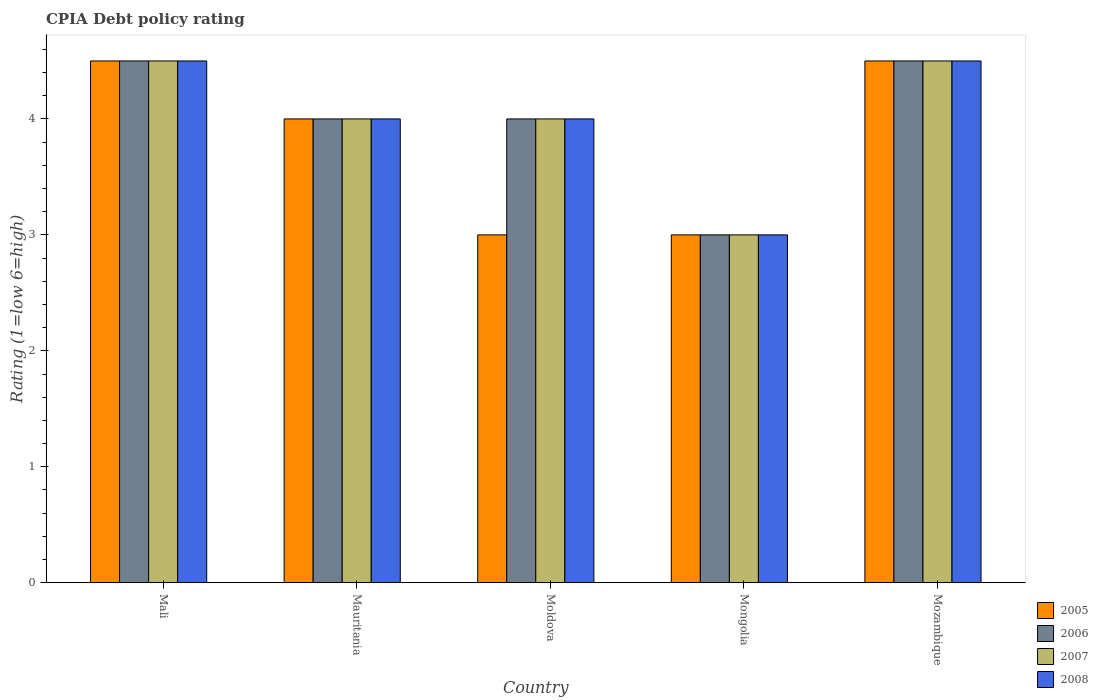How many different coloured bars are there?
Give a very brief answer. 4. How many groups of bars are there?
Provide a succinct answer. 5. Are the number of bars on each tick of the X-axis equal?
Offer a terse response. Yes. How many bars are there on the 3rd tick from the right?
Give a very brief answer. 4. What is the label of the 1st group of bars from the left?
Provide a succinct answer. Mali. In how many cases, is the number of bars for a given country not equal to the number of legend labels?
Keep it short and to the point. 0. In which country was the CPIA rating in 2008 maximum?
Your answer should be compact. Mali. In which country was the CPIA rating in 2005 minimum?
Provide a succinct answer. Moldova. What is the total CPIA rating in 2005 in the graph?
Provide a short and direct response. 19. What is the difference between the CPIA rating in 2008 in Moldova and that in Mozambique?
Your answer should be compact. -0.5. What is the difference between the CPIA rating in 2007 in Moldova and the CPIA rating in 2006 in Mongolia?
Offer a terse response. 1. What is the average CPIA rating in 2005 per country?
Your answer should be very brief. 3.8. What is the difference between the CPIA rating of/in 2008 and CPIA rating of/in 2006 in Moldova?
Keep it short and to the point. 0. In how many countries, is the CPIA rating in 2008 greater than 2.8?
Offer a very short reply. 5. What is the ratio of the CPIA rating in 2005 in Mauritania to that in Mongolia?
Make the answer very short. 1.33. Is the CPIA rating in 2006 in Mali less than that in Moldova?
Offer a very short reply. No. What is the difference between the highest and the second highest CPIA rating in 2007?
Offer a very short reply. 0.5. What is the difference between the highest and the lowest CPIA rating in 2005?
Keep it short and to the point. 1.5. What does the 3rd bar from the left in Mongolia represents?
Give a very brief answer. 2007. Is it the case that in every country, the sum of the CPIA rating in 2005 and CPIA rating in 2008 is greater than the CPIA rating in 2007?
Your answer should be compact. Yes. Are the values on the major ticks of Y-axis written in scientific E-notation?
Make the answer very short. No. Does the graph contain any zero values?
Your response must be concise. No. How many legend labels are there?
Offer a terse response. 4. How are the legend labels stacked?
Ensure brevity in your answer.  Vertical. What is the title of the graph?
Offer a very short reply. CPIA Debt policy rating. What is the label or title of the X-axis?
Give a very brief answer. Country. What is the label or title of the Y-axis?
Keep it short and to the point. Rating (1=low 6=high). What is the Rating (1=low 6=high) of 2008 in Mali?
Provide a succinct answer. 4.5. What is the Rating (1=low 6=high) in 2005 in Mauritania?
Offer a very short reply. 4. What is the Rating (1=low 6=high) in 2006 in Mauritania?
Keep it short and to the point. 4. What is the Rating (1=low 6=high) in 2005 in Moldova?
Give a very brief answer. 3. What is the Rating (1=low 6=high) in 2006 in Moldova?
Offer a very short reply. 4. What is the Rating (1=low 6=high) in 2007 in Moldova?
Give a very brief answer. 4. What is the Rating (1=low 6=high) of 2008 in Mongolia?
Keep it short and to the point. 3. What is the Rating (1=low 6=high) in 2005 in Mozambique?
Your answer should be compact. 4.5. What is the Rating (1=low 6=high) in 2006 in Mozambique?
Provide a succinct answer. 4.5. What is the Rating (1=low 6=high) of 2008 in Mozambique?
Make the answer very short. 4.5. Across all countries, what is the maximum Rating (1=low 6=high) of 2006?
Your response must be concise. 4.5. Across all countries, what is the maximum Rating (1=low 6=high) of 2007?
Your answer should be compact. 4.5. Across all countries, what is the maximum Rating (1=low 6=high) of 2008?
Make the answer very short. 4.5. Across all countries, what is the minimum Rating (1=low 6=high) of 2005?
Your response must be concise. 3. Across all countries, what is the minimum Rating (1=low 6=high) in 2006?
Your answer should be very brief. 3. Across all countries, what is the minimum Rating (1=low 6=high) of 2007?
Your answer should be compact. 3. Across all countries, what is the minimum Rating (1=low 6=high) in 2008?
Provide a short and direct response. 3. What is the total Rating (1=low 6=high) of 2005 in the graph?
Offer a very short reply. 19. What is the total Rating (1=low 6=high) of 2008 in the graph?
Offer a terse response. 20. What is the difference between the Rating (1=low 6=high) of 2005 in Mali and that in Mauritania?
Offer a terse response. 0.5. What is the difference between the Rating (1=low 6=high) in 2007 in Mali and that in Mauritania?
Make the answer very short. 0.5. What is the difference between the Rating (1=low 6=high) in 2008 in Mali and that in Mauritania?
Make the answer very short. 0.5. What is the difference between the Rating (1=low 6=high) of 2005 in Mali and that in Mongolia?
Keep it short and to the point. 1.5. What is the difference between the Rating (1=low 6=high) in 2007 in Mali and that in Mongolia?
Provide a succinct answer. 1.5. What is the difference between the Rating (1=low 6=high) in 2008 in Mali and that in Mongolia?
Offer a terse response. 1.5. What is the difference between the Rating (1=low 6=high) of 2006 in Mali and that in Mozambique?
Your answer should be compact. 0. What is the difference between the Rating (1=low 6=high) in 2008 in Mali and that in Mozambique?
Offer a very short reply. 0. What is the difference between the Rating (1=low 6=high) in 2006 in Mauritania and that in Moldova?
Offer a terse response. 0. What is the difference between the Rating (1=low 6=high) in 2007 in Mauritania and that in Moldova?
Make the answer very short. 0. What is the difference between the Rating (1=low 6=high) in 2008 in Mauritania and that in Moldova?
Provide a succinct answer. 0. What is the difference between the Rating (1=low 6=high) of 2008 in Mauritania and that in Mongolia?
Your answer should be very brief. 1. What is the difference between the Rating (1=low 6=high) of 2005 in Mauritania and that in Mozambique?
Offer a very short reply. -0.5. What is the difference between the Rating (1=low 6=high) in 2006 in Mauritania and that in Mozambique?
Offer a terse response. -0.5. What is the difference between the Rating (1=low 6=high) in 2007 in Mauritania and that in Mozambique?
Your answer should be very brief. -0.5. What is the difference between the Rating (1=low 6=high) in 2005 in Moldova and that in Mongolia?
Your answer should be very brief. 0. What is the difference between the Rating (1=low 6=high) of 2007 in Moldova and that in Mongolia?
Provide a succinct answer. 1. What is the difference between the Rating (1=low 6=high) in 2008 in Moldova and that in Mongolia?
Provide a succinct answer. 1. What is the difference between the Rating (1=low 6=high) in 2005 in Moldova and that in Mozambique?
Your answer should be very brief. -1.5. What is the difference between the Rating (1=low 6=high) of 2006 in Moldova and that in Mozambique?
Your answer should be compact. -0.5. What is the difference between the Rating (1=low 6=high) of 2007 in Moldova and that in Mozambique?
Provide a succinct answer. -0.5. What is the difference between the Rating (1=low 6=high) in 2008 in Moldova and that in Mozambique?
Ensure brevity in your answer.  -0.5. What is the difference between the Rating (1=low 6=high) in 2006 in Mongolia and that in Mozambique?
Keep it short and to the point. -1.5. What is the difference between the Rating (1=low 6=high) in 2005 in Mali and the Rating (1=low 6=high) in 2006 in Mauritania?
Give a very brief answer. 0.5. What is the difference between the Rating (1=low 6=high) of 2005 in Mali and the Rating (1=low 6=high) of 2008 in Mauritania?
Ensure brevity in your answer.  0.5. What is the difference between the Rating (1=low 6=high) in 2006 in Mali and the Rating (1=low 6=high) in 2007 in Mauritania?
Keep it short and to the point. 0.5. What is the difference between the Rating (1=low 6=high) of 2007 in Mali and the Rating (1=low 6=high) of 2008 in Mauritania?
Provide a succinct answer. 0.5. What is the difference between the Rating (1=low 6=high) in 2006 in Mali and the Rating (1=low 6=high) in 2008 in Moldova?
Provide a short and direct response. 0.5. What is the difference between the Rating (1=low 6=high) of 2005 in Mali and the Rating (1=low 6=high) of 2006 in Mozambique?
Your answer should be compact. 0. What is the difference between the Rating (1=low 6=high) of 2006 in Mali and the Rating (1=low 6=high) of 2008 in Mozambique?
Keep it short and to the point. 0. What is the difference between the Rating (1=low 6=high) in 2005 in Mauritania and the Rating (1=low 6=high) in 2006 in Moldova?
Your answer should be compact. 0. What is the difference between the Rating (1=low 6=high) in 2006 in Mauritania and the Rating (1=low 6=high) in 2008 in Mongolia?
Your response must be concise. 1. What is the difference between the Rating (1=low 6=high) of 2005 in Mauritania and the Rating (1=low 6=high) of 2006 in Mozambique?
Your answer should be very brief. -0.5. What is the difference between the Rating (1=low 6=high) in 2005 in Mauritania and the Rating (1=low 6=high) in 2007 in Mozambique?
Ensure brevity in your answer.  -0.5. What is the difference between the Rating (1=low 6=high) of 2005 in Mauritania and the Rating (1=low 6=high) of 2008 in Mozambique?
Provide a short and direct response. -0.5. What is the difference between the Rating (1=low 6=high) in 2006 in Mauritania and the Rating (1=low 6=high) in 2007 in Mozambique?
Your answer should be very brief. -0.5. What is the difference between the Rating (1=low 6=high) of 2007 in Mauritania and the Rating (1=low 6=high) of 2008 in Mozambique?
Provide a succinct answer. -0.5. What is the difference between the Rating (1=low 6=high) in 2005 in Moldova and the Rating (1=low 6=high) in 2007 in Mongolia?
Ensure brevity in your answer.  0. What is the difference between the Rating (1=low 6=high) of 2005 in Moldova and the Rating (1=low 6=high) of 2008 in Mongolia?
Make the answer very short. 0. What is the difference between the Rating (1=low 6=high) in 2006 in Moldova and the Rating (1=low 6=high) in 2007 in Mongolia?
Your answer should be very brief. 1. What is the difference between the Rating (1=low 6=high) of 2006 in Moldova and the Rating (1=low 6=high) of 2008 in Mongolia?
Offer a very short reply. 1. What is the difference between the Rating (1=low 6=high) of 2007 in Moldova and the Rating (1=low 6=high) of 2008 in Mongolia?
Your answer should be compact. 1. What is the difference between the Rating (1=low 6=high) of 2005 in Moldova and the Rating (1=low 6=high) of 2006 in Mozambique?
Your response must be concise. -1.5. What is the difference between the Rating (1=low 6=high) of 2005 in Moldova and the Rating (1=low 6=high) of 2007 in Mozambique?
Offer a terse response. -1.5. What is the difference between the Rating (1=low 6=high) in 2006 in Moldova and the Rating (1=low 6=high) in 2007 in Mozambique?
Your answer should be compact. -0.5. What is the difference between the Rating (1=low 6=high) of 2007 in Moldova and the Rating (1=low 6=high) of 2008 in Mozambique?
Make the answer very short. -0.5. What is the difference between the Rating (1=low 6=high) of 2005 in Mongolia and the Rating (1=low 6=high) of 2006 in Mozambique?
Your answer should be compact. -1.5. What is the difference between the Rating (1=low 6=high) in 2005 in Mongolia and the Rating (1=low 6=high) in 2008 in Mozambique?
Provide a short and direct response. -1.5. What is the difference between the Rating (1=low 6=high) in 2006 in Mongolia and the Rating (1=low 6=high) in 2008 in Mozambique?
Offer a very short reply. -1.5. What is the difference between the Rating (1=low 6=high) of 2007 in Mongolia and the Rating (1=low 6=high) of 2008 in Mozambique?
Ensure brevity in your answer.  -1.5. What is the average Rating (1=low 6=high) in 2007 per country?
Make the answer very short. 4. What is the difference between the Rating (1=low 6=high) in 2005 and Rating (1=low 6=high) in 2007 in Mali?
Offer a very short reply. 0. What is the difference between the Rating (1=low 6=high) in 2006 and Rating (1=low 6=high) in 2008 in Mali?
Give a very brief answer. 0. What is the difference between the Rating (1=low 6=high) of 2007 and Rating (1=low 6=high) of 2008 in Mali?
Provide a short and direct response. 0. What is the difference between the Rating (1=low 6=high) in 2005 and Rating (1=low 6=high) in 2006 in Mauritania?
Keep it short and to the point. 0. What is the difference between the Rating (1=low 6=high) in 2005 and Rating (1=low 6=high) in 2007 in Mauritania?
Offer a terse response. 0. What is the difference between the Rating (1=low 6=high) of 2006 and Rating (1=low 6=high) of 2007 in Mauritania?
Offer a very short reply. 0. What is the difference between the Rating (1=low 6=high) of 2006 and Rating (1=low 6=high) of 2008 in Mauritania?
Keep it short and to the point. 0. What is the difference between the Rating (1=low 6=high) of 2005 and Rating (1=low 6=high) of 2007 in Moldova?
Ensure brevity in your answer.  -1. What is the difference between the Rating (1=low 6=high) in 2005 and Rating (1=low 6=high) in 2008 in Moldova?
Give a very brief answer. -1. What is the difference between the Rating (1=low 6=high) in 2006 and Rating (1=low 6=high) in 2008 in Moldova?
Provide a short and direct response. 0. What is the difference between the Rating (1=low 6=high) in 2007 and Rating (1=low 6=high) in 2008 in Moldova?
Your answer should be compact. 0. What is the difference between the Rating (1=low 6=high) in 2007 and Rating (1=low 6=high) in 2008 in Mongolia?
Offer a very short reply. 0. What is the difference between the Rating (1=low 6=high) in 2005 and Rating (1=low 6=high) in 2006 in Mozambique?
Ensure brevity in your answer.  0. What is the difference between the Rating (1=low 6=high) of 2005 and Rating (1=low 6=high) of 2008 in Mozambique?
Your response must be concise. 0. What is the difference between the Rating (1=low 6=high) in 2006 and Rating (1=low 6=high) in 2007 in Mozambique?
Keep it short and to the point. 0. What is the difference between the Rating (1=low 6=high) of 2007 and Rating (1=low 6=high) of 2008 in Mozambique?
Give a very brief answer. 0. What is the ratio of the Rating (1=low 6=high) in 2005 in Mali to that in Mauritania?
Keep it short and to the point. 1.12. What is the ratio of the Rating (1=low 6=high) in 2006 in Mali to that in Mauritania?
Give a very brief answer. 1.12. What is the ratio of the Rating (1=low 6=high) of 2007 in Mali to that in Mauritania?
Give a very brief answer. 1.12. What is the ratio of the Rating (1=low 6=high) in 2008 in Mali to that in Mauritania?
Ensure brevity in your answer.  1.12. What is the ratio of the Rating (1=low 6=high) in 2006 in Mali to that in Moldova?
Your response must be concise. 1.12. What is the ratio of the Rating (1=low 6=high) in 2007 in Mali to that in Moldova?
Make the answer very short. 1.12. What is the ratio of the Rating (1=low 6=high) in 2008 in Mali to that in Moldova?
Ensure brevity in your answer.  1.12. What is the ratio of the Rating (1=low 6=high) in 2005 in Mali to that in Mongolia?
Ensure brevity in your answer.  1.5. What is the ratio of the Rating (1=low 6=high) of 2007 in Mali to that in Mongolia?
Provide a succinct answer. 1.5. What is the ratio of the Rating (1=low 6=high) in 2008 in Mali to that in Mongolia?
Provide a succinct answer. 1.5. What is the ratio of the Rating (1=low 6=high) of 2008 in Mali to that in Mozambique?
Provide a succinct answer. 1. What is the ratio of the Rating (1=low 6=high) of 2006 in Mauritania to that in Moldova?
Offer a terse response. 1. What is the ratio of the Rating (1=low 6=high) of 2007 in Mauritania to that in Moldova?
Provide a succinct answer. 1. What is the ratio of the Rating (1=low 6=high) of 2005 in Mauritania to that in Mongolia?
Give a very brief answer. 1.33. What is the ratio of the Rating (1=low 6=high) of 2007 in Mauritania to that in Mongolia?
Offer a very short reply. 1.33. What is the ratio of the Rating (1=low 6=high) of 2008 in Mauritania to that in Mongolia?
Keep it short and to the point. 1.33. What is the ratio of the Rating (1=low 6=high) of 2007 in Mauritania to that in Mozambique?
Offer a terse response. 0.89. What is the ratio of the Rating (1=low 6=high) of 2008 in Mauritania to that in Mozambique?
Provide a succinct answer. 0.89. What is the ratio of the Rating (1=low 6=high) of 2005 in Moldova to that in Mongolia?
Offer a terse response. 1. What is the ratio of the Rating (1=low 6=high) of 2006 in Moldova to that in Mongolia?
Provide a succinct answer. 1.33. What is the ratio of the Rating (1=low 6=high) in 2007 in Moldova to that in Mongolia?
Give a very brief answer. 1.33. What is the ratio of the Rating (1=low 6=high) of 2005 in Moldova to that in Mozambique?
Provide a short and direct response. 0.67. What is the ratio of the Rating (1=low 6=high) in 2006 in Moldova to that in Mozambique?
Your answer should be very brief. 0.89. What is the ratio of the Rating (1=low 6=high) of 2008 in Moldova to that in Mozambique?
Ensure brevity in your answer.  0.89. What is the ratio of the Rating (1=low 6=high) of 2005 in Mongolia to that in Mozambique?
Your answer should be very brief. 0.67. What is the ratio of the Rating (1=low 6=high) in 2007 in Mongolia to that in Mozambique?
Keep it short and to the point. 0.67. What is the ratio of the Rating (1=low 6=high) of 2008 in Mongolia to that in Mozambique?
Your answer should be very brief. 0.67. What is the difference between the highest and the second highest Rating (1=low 6=high) of 2005?
Provide a succinct answer. 0. What is the difference between the highest and the second highest Rating (1=low 6=high) in 2006?
Your answer should be very brief. 0. What is the difference between the highest and the second highest Rating (1=low 6=high) in 2007?
Your response must be concise. 0. 